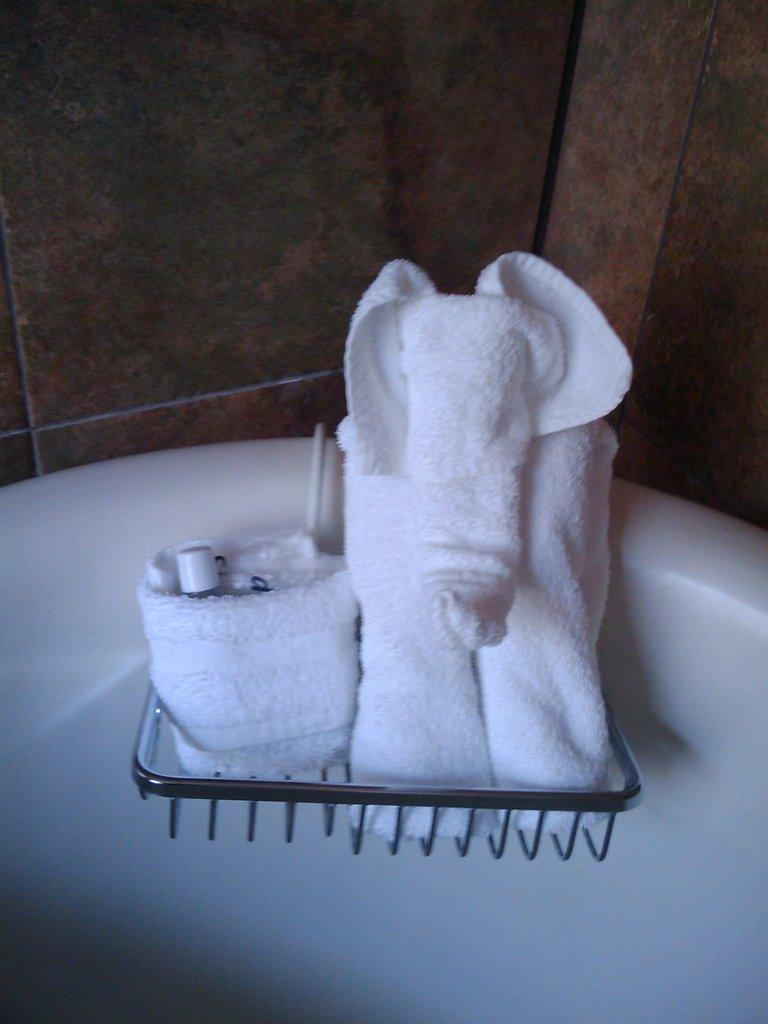What is the main object in the image? There is a stand in the image. What is placed on the stand? Towels are present on the stand. Can you describe the white object in the image? There is a white object in the image, but its specific details are not clear from the provided facts. What can be seen in the background of the image? There is a wall in the background of the image. What condition is the wrench in when it drops from the stand in the image? There is no wrench present in the image, and therefore no such event can be observed. 